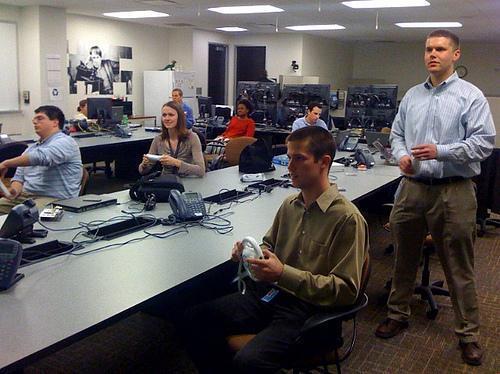How many people are standing?
Give a very brief answer. 1. How many people in this photo appear to be holding gaming controllers?
Give a very brief answer. 4. How many people are standing?
Give a very brief answer. 1. How many people can you see?
Give a very brief answer. 4. 